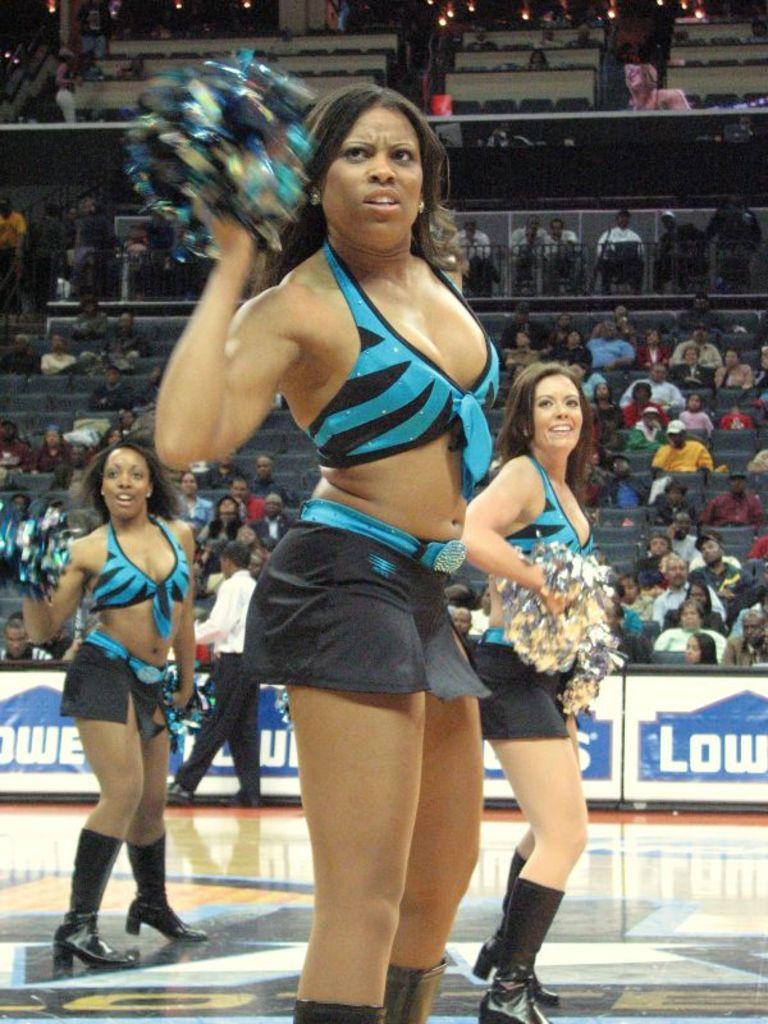Could you give a brief overview of what you see in this image? In this picture we can see Cheerleading girls. In the background we can see audience. This is a hoarding. At the top we can see lights. 